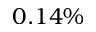<formula> <loc_0><loc_0><loc_500><loc_500>0 . 1 4 \%</formula> 